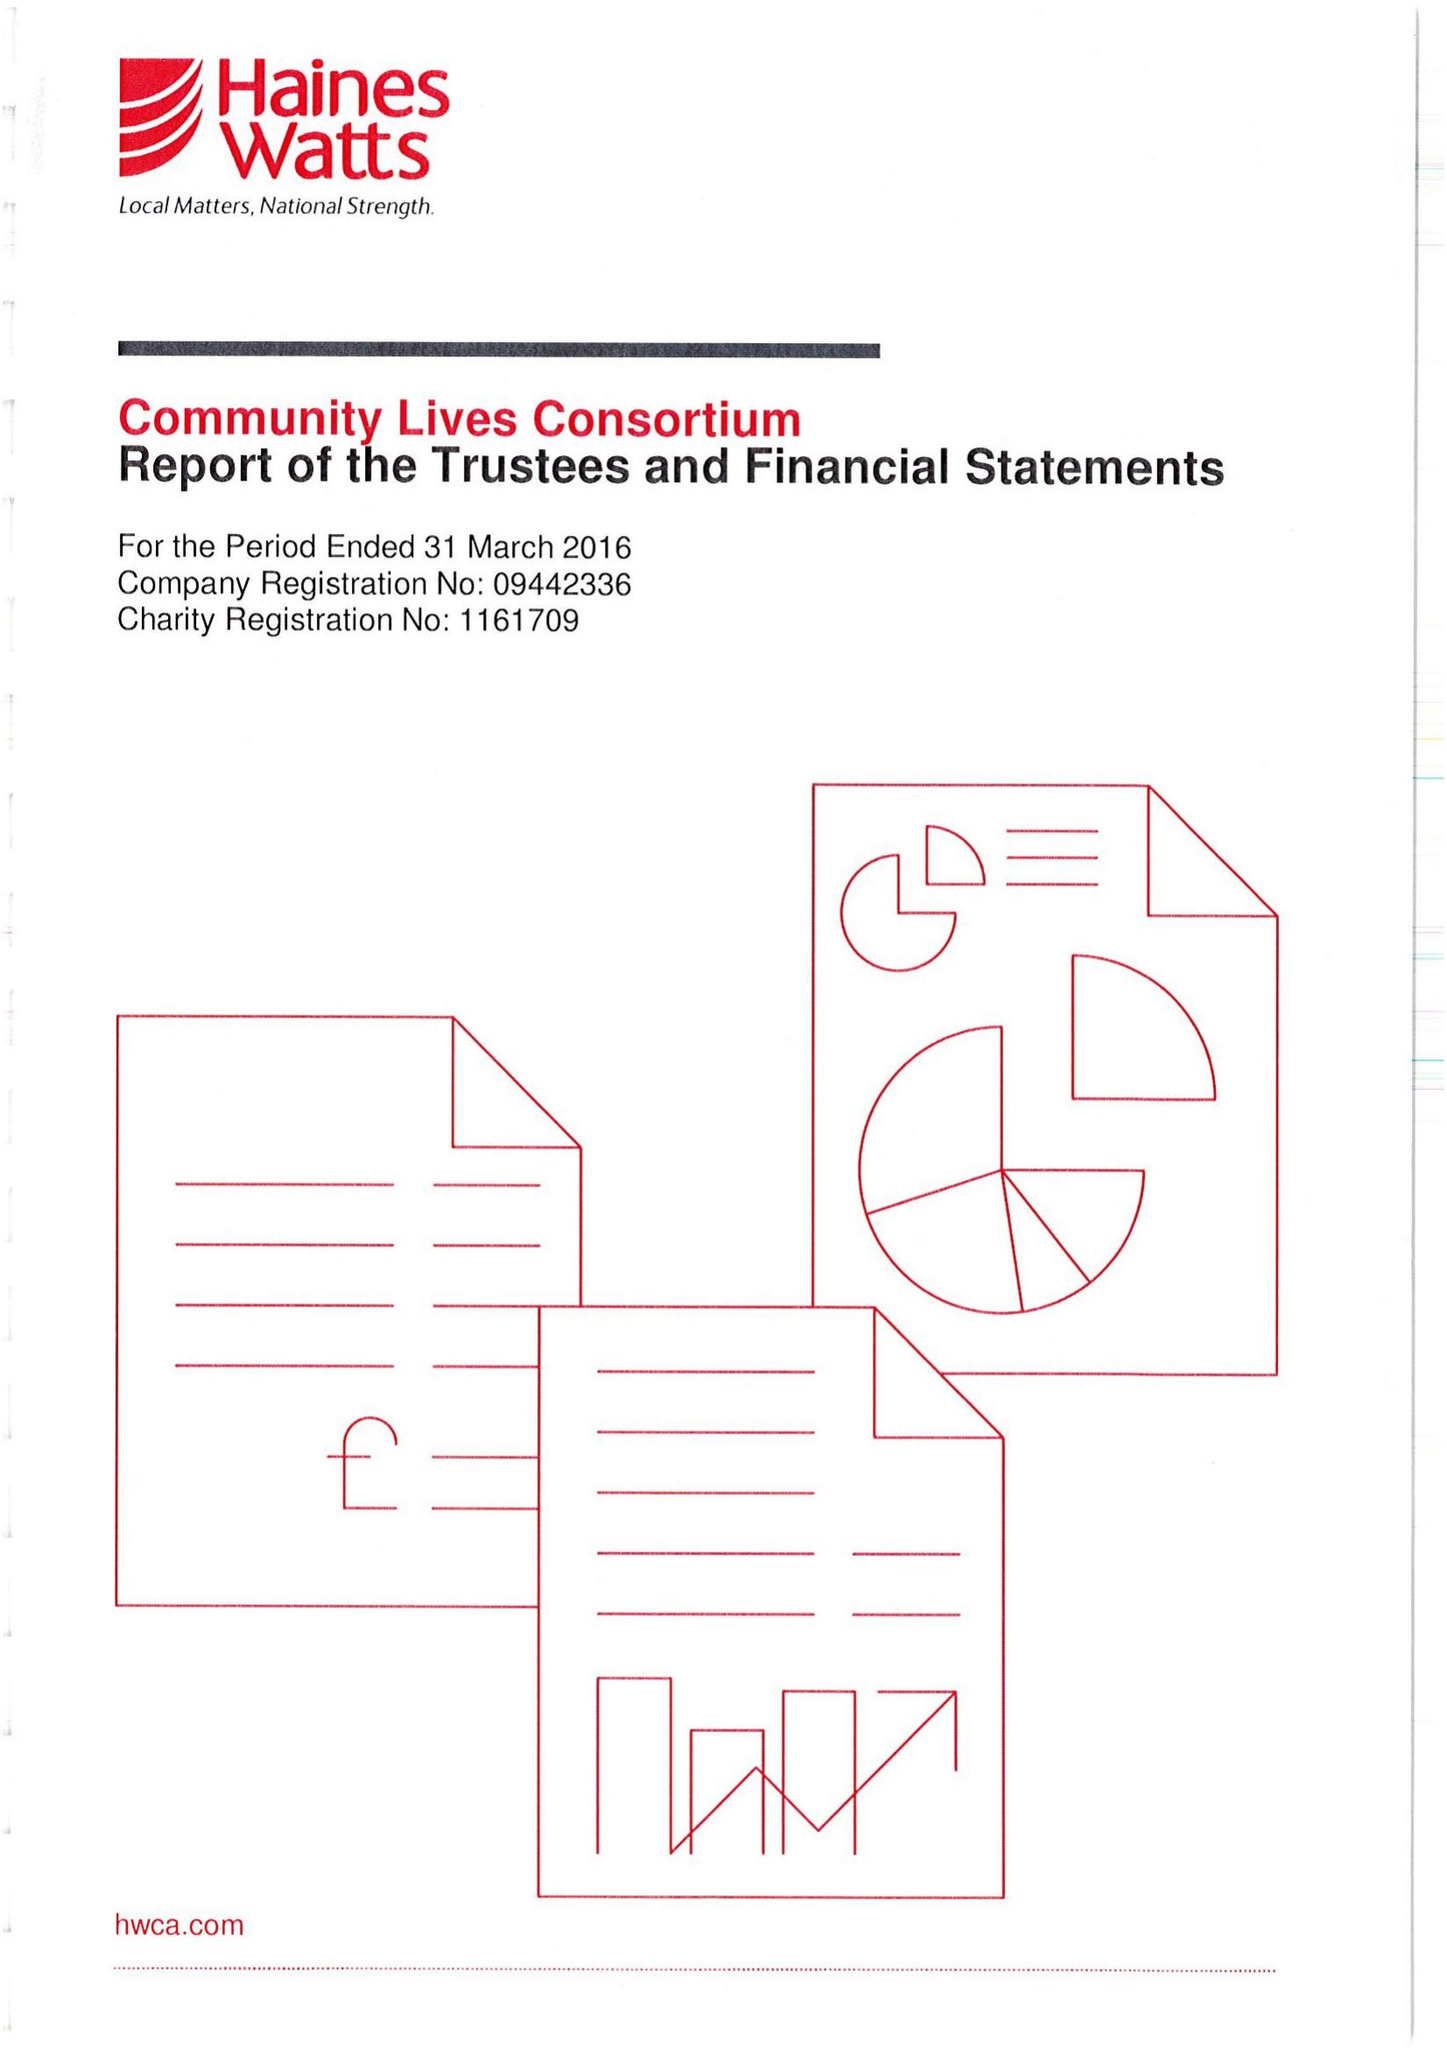What is the value for the charity_number?
Answer the question using a single word or phrase. 1161709 